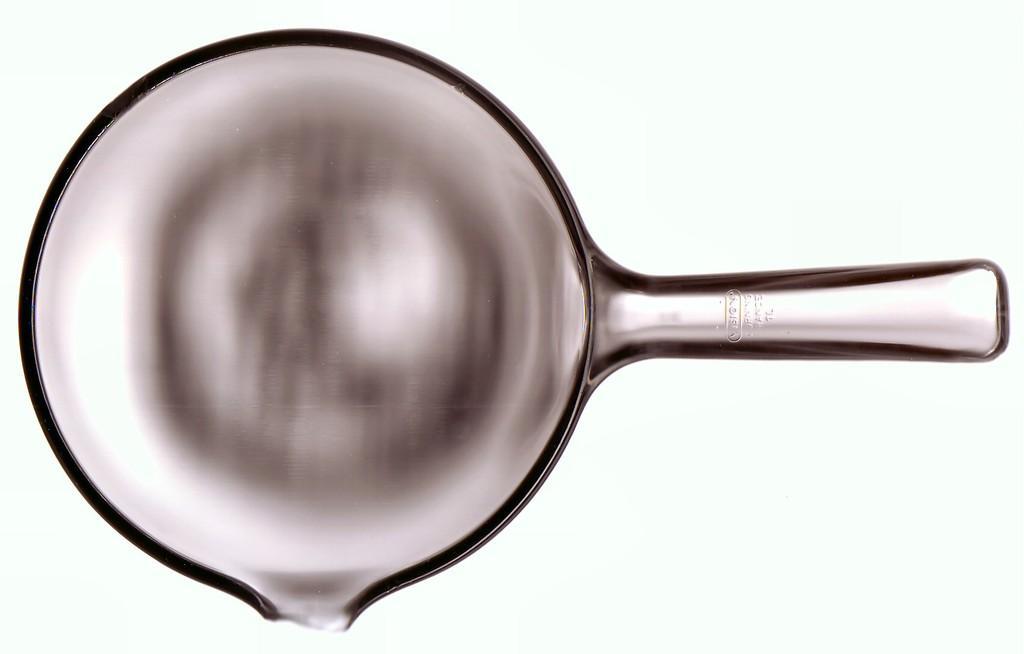Could you give a brief overview of what you see in this image? In the picture I can see a pan. The background of the image is in white color. 